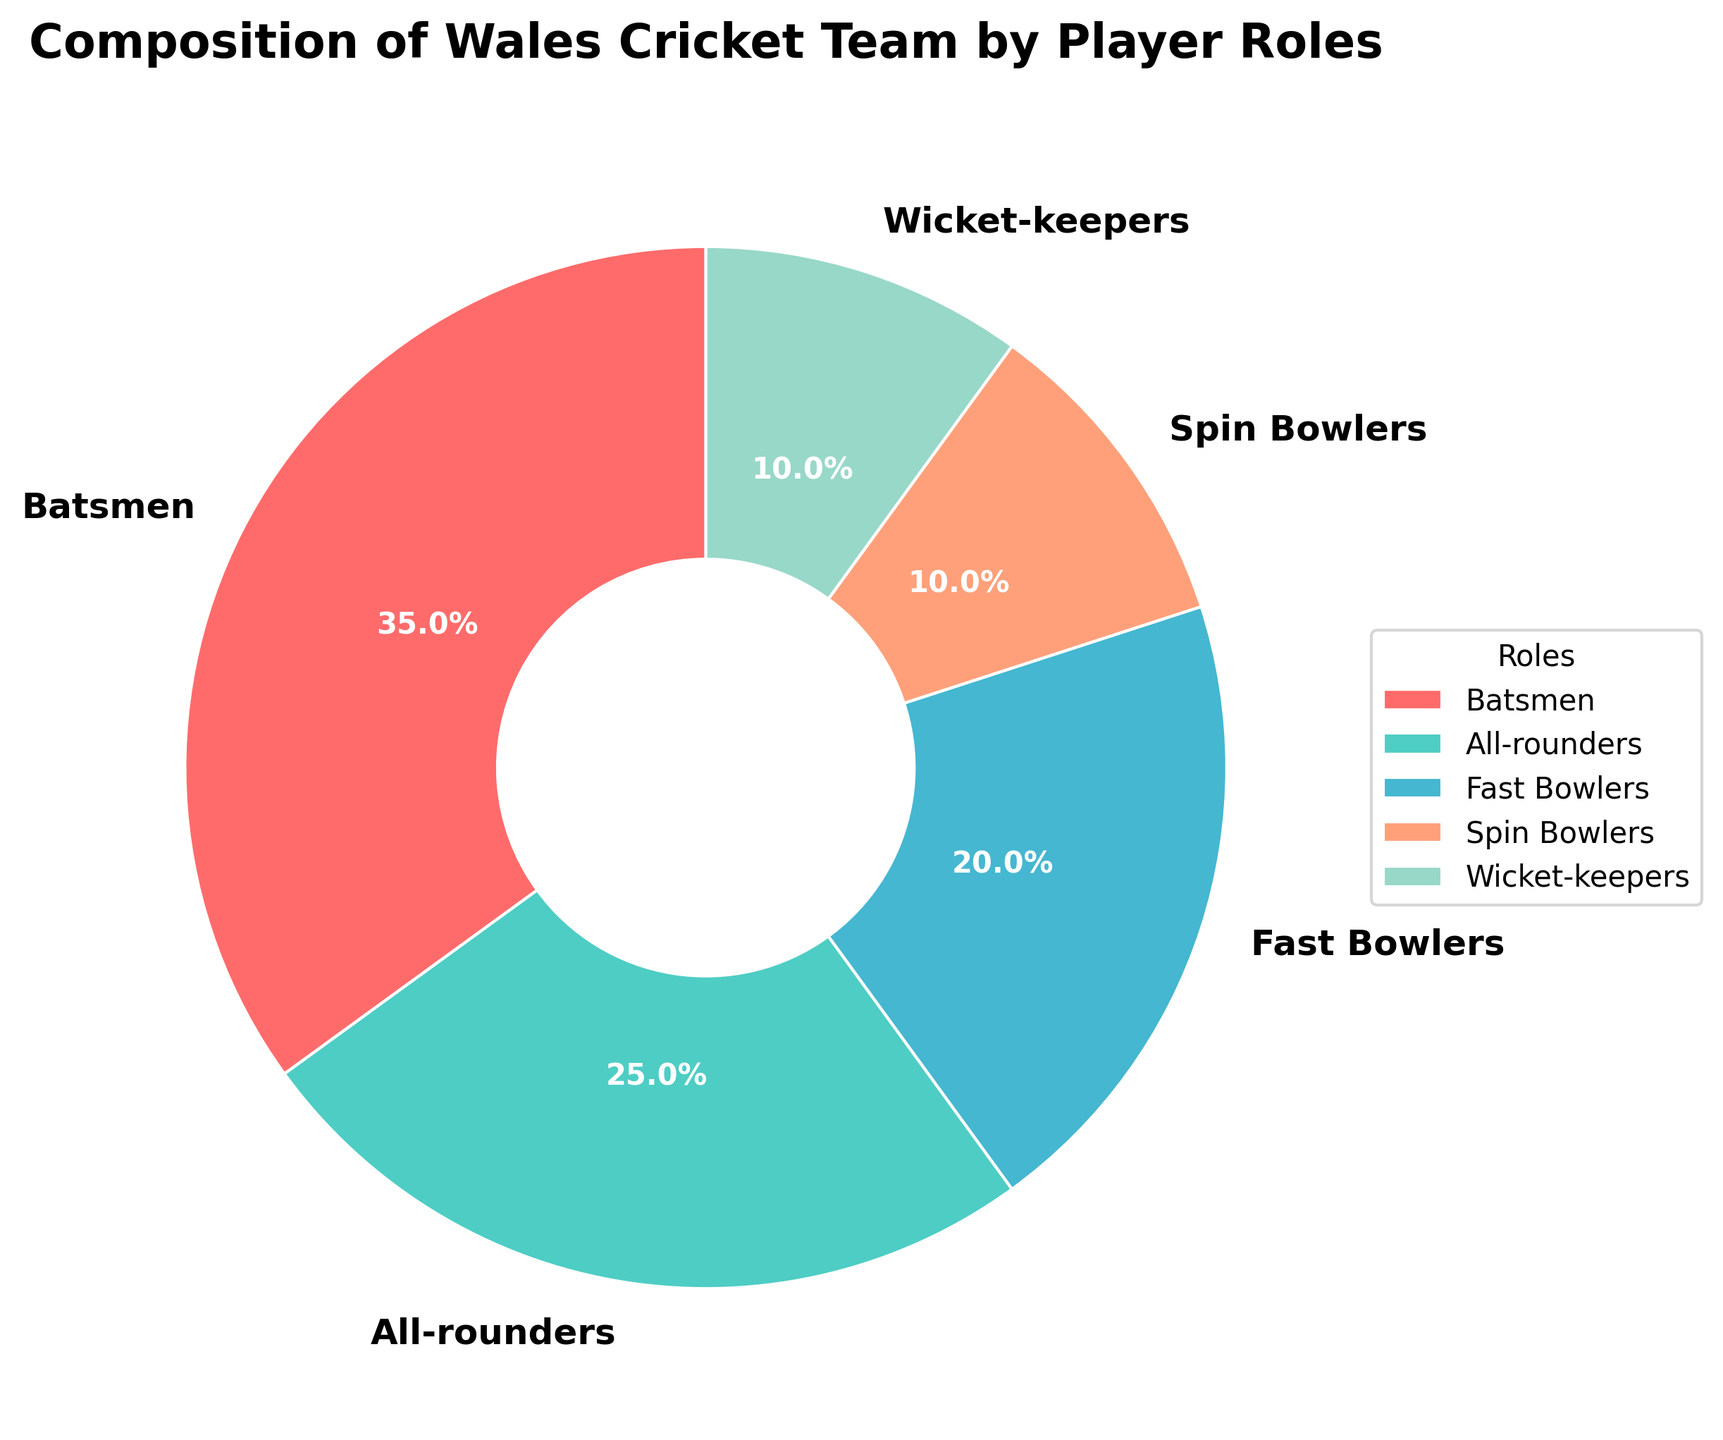What percentage of the Wales cricket team is composed of specialist bowlers (both fast and spin)? Add the percentage of fast bowlers (20%) and spin bowlers (10%). 20% + 10% = 30%
Answer: 30% Which role has the highest representation in the Wales cricket team? Look for the role with the highest percentage in the pie chart. Batsmen have the highest representation at 35%.
Answer: Batsmen Are there more all-rounders or fast bowlers in the team? Compare the percentages of all-rounders (25%) and fast bowlers (20%). All-rounders have a higher percentage than fast bowlers.
Answer: All-rounders What is the difference in representation between batsmen and wicket-keepers? Subtract the percentage of wicket-keepers (10%) from the percentage of batsmen (35%). 35% - 10% = 25%
Answer: 25% How much greater is the percentage of batsmen compared to spin bowlers? Subtract the percentage of spin bowlers (10%) from the percentage of batsmen (35%). 35% - 10% = 25%
Answer: 25% What percentage of the team is composed of players who are not bowlers? Subtract the combined percentage of fast and spin bowlers (30%) from 100%. 100% - 30% = 70%
Answer: 70% What role has the smallest representation in the team? Look for the role with the smallest percentage in the pie chart. Both spin bowlers and wicket-keepers have the smallest representation at 10%.
Answer: Spin bowlers and wicket-keepers Are batsmen and all-rounders combined more than half of the team? Add the percentages of batsmen (35%) and all-rounders (25%). 35% + 25% = 60%, which is more than half.
Answer: Yes Which role is closest in percentage to wicket-keepers? Compare the percentages of different roles; spin bowlers also have 10%, making them closest to wicket-keepers.
Answer: Spin bowlers What is the second largest group in the team by player role? Identify the role with the second highest percentage after batsmen. All-rounders have the second highest percentage at 25%.
Answer: All-rounders 